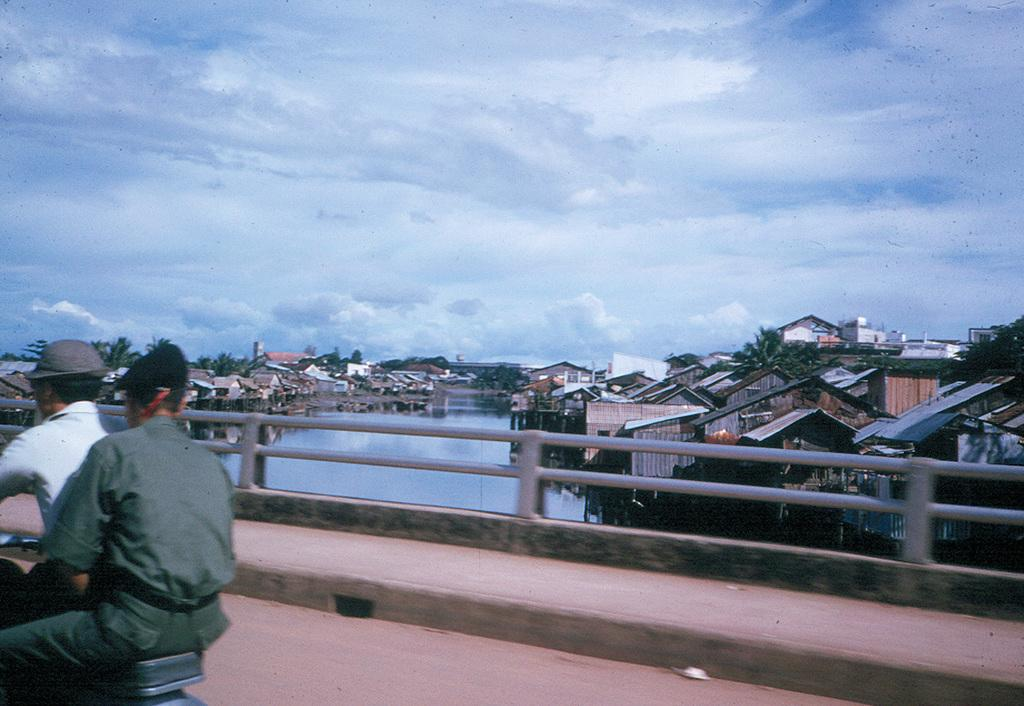How many people are in the image? There are two people in the image. What are the people wearing? Both people are wearing clothes. Can you describe the headwear of one of the people? One person is wearing a hat. What are the people doing in the image? The two people are riding on a two-wheeler. What can be seen in the background of the image? There is a fence, buildings, trees, and water visible in the image. How would you describe the sky in the image? The sky is cloudy and pale blue. What type of clam can be seen in the image? There are no clams present in the image. Can you tell me the credit score of the person wearing the hat in the image? There is no information about the credit score of the person wearing the hat in the image. 